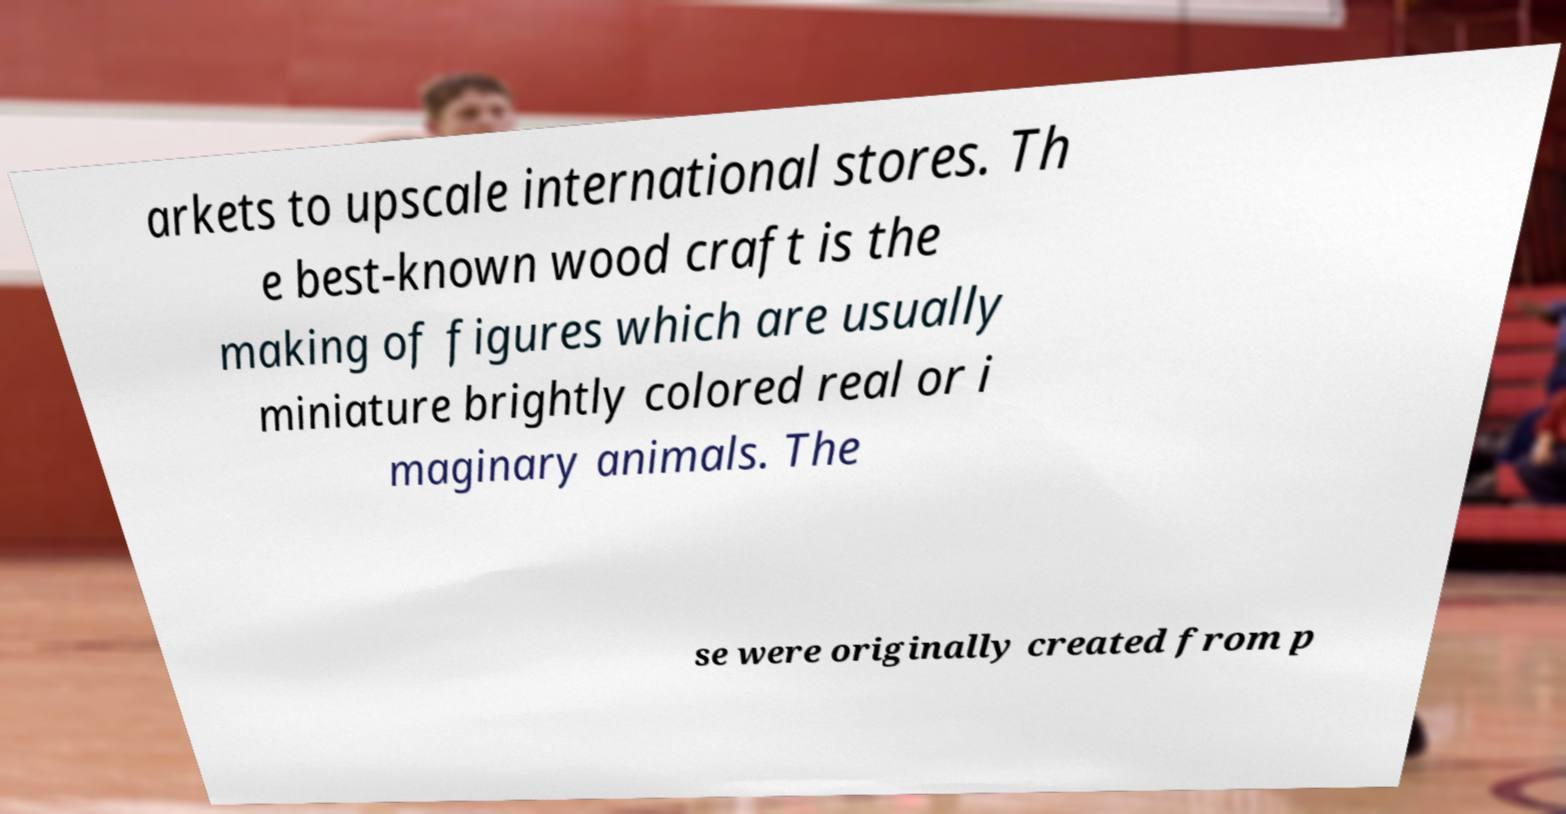Could you extract and type out the text from this image? arkets to upscale international stores. Th e best-known wood craft is the making of figures which are usually miniature brightly colored real or i maginary animals. The se were originally created from p 